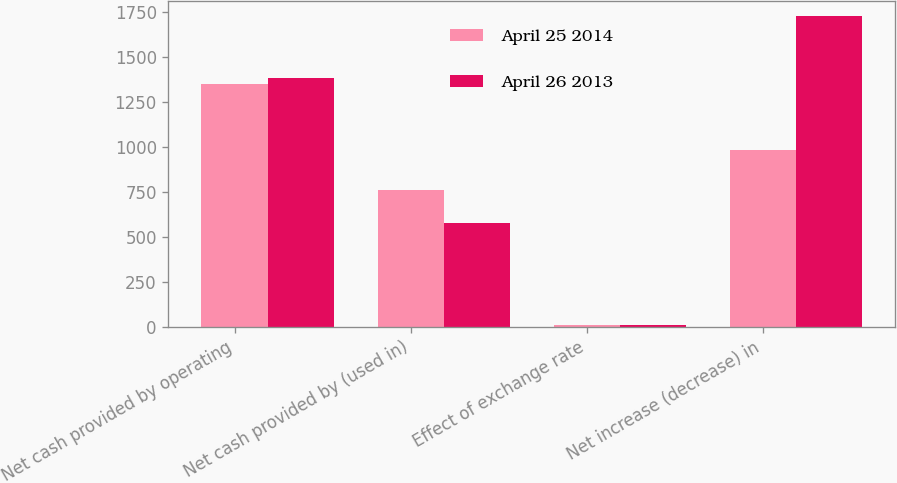Convert chart. <chart><loc_0><loc_0><loc_500><loc_500><stacked_bar_chart><ecel><fcel>Net cash provided by operating<fcel>Net cash provided by (used in)<fcel>Effect of exchange rate<fcel>Net increase (decrease) in<nl><fcel>April 25 2014<fcel>1349.6<fcel>760.4<fcel>7.9<fcel>986.1<nl><fcel>April 26 2013<fcel>1386.3<fcel>578.9<fcel>9.3<fcel>1727.3<nl></chart> 